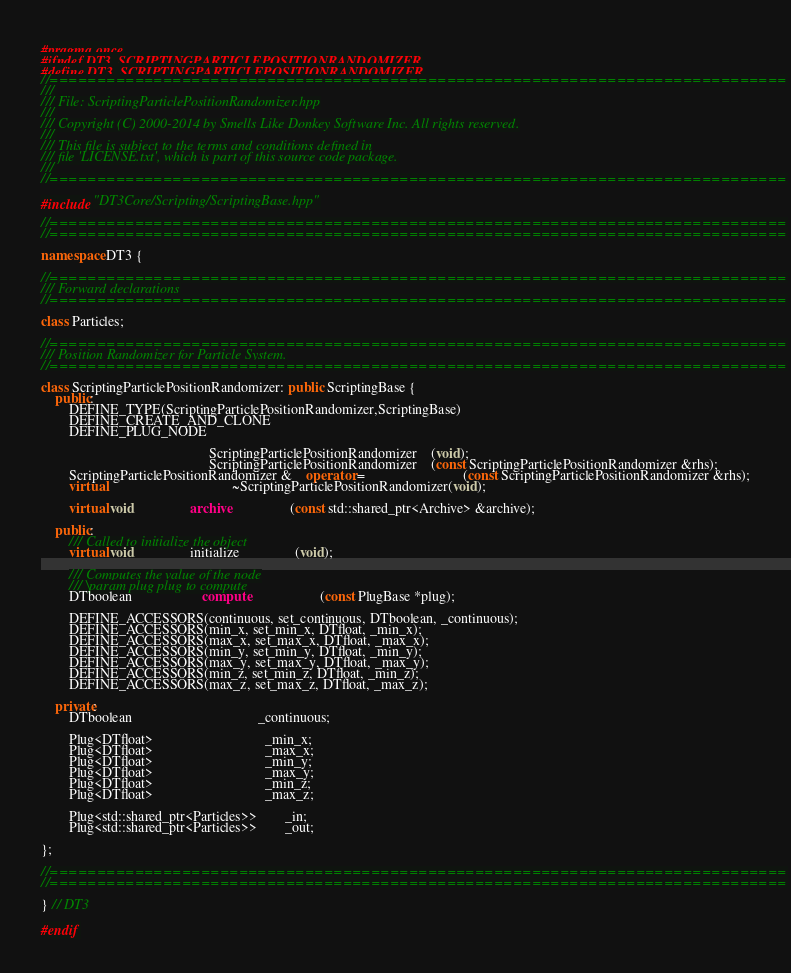<code> <loc_0><loc_0><loc_500><loc_500><_C++_>#pragma once
#ifndef DT3_SCRIPTINGPARTICLEPOSITIONRANDOMIZER
#define DT3_SCRIPTINGPARTICLEPOSITIONRANDOMIZER
//==============================================================================
///
///	File: ScriptingParticlePositionRandomizer.hpp
///
/// Copyright (C) 2000-2014 by Smells Like Donkey Software Inc. All rights reserved.
///
/// This file is subject to the terms and conditions defined in
/// file 'LICENSE.txt', which is part of this source code package.
///
//==============================================================================

#include "DT3Core/Scripting/ScriptingBase.hpp"

//==============================================================================
//==============================================================================

namespace DT3 {

//==============================================================================
/// Forward declarations
//==============================================================================

class Particles;

//==============================================================================
/// Position Randomizer for Particle System.
//==============================================================================

class ScriptingParticlePositionRandomizer: public ScriptingBase {
    public:
        DEFINE_TYPE(ScriptingParticlePositionRandomizer,ScriptingBase)
        DEFINE_CREATE_AND_CLONE
        DEFINE_PLUG_NODE

                                                ScriptingParticlePositionRandomizer	(void);
                                                ScriptingParticlePositionRandomizer	(const ScriptingParticlePositionRandomizer &rhs);
        ScriptingParticlePositionRandomizer &	operator =							(const ScriptingParticlePositionRandomizer &rhs);
        virtual									~ScriptingParticlePositionRandomizer(void);

        virtual void                archive                 (const std::shared_ptr<Archive> &archive);

    public:
        /// Called to initialize the object
        virtual void				initialize				(void);

        /// Computes the value of the node
        /// \param plug plug to compute
        DTboolean					compute					(const PlugBase *plug);

        DEFINE_ACCESSORS(continuous, set_continuous, DTboolean, _continuous);
        DEFINE_ACCESSORS(min_x, set_min_x, DTfloat, _min_x);
        DEFINE_ACCESSORS(max_x, set_max_x, DTfloat, _max_x);
        DEFINE_ACCESSORS(min_y, set_min_y, DTfloat, _min_y);
        DEFINE_ACCESSORS(max_y, set_max_y, DTfloat, _max_y);
        DEFINE_ACCESSORS(min_z, set_min_z, DTfloat, _min_z);
        DEFINE_ACCESSORS(max_z, set_max_z, DTfloat, _max_z);

    private:
        DTboolean									_continuous;

        Plug<DTfloat>								_min_x;
        Plug<DTfloat>								_max_x;
        Plug<DTfloat>								_min_y;
        Plug<DTfloat>								_max_y;
        Plug<DTfloat>								_min_z;
        Plug<DTfloat>								_max_z;

        Plug<std::shared_ptr<Particles>>		_in;
        Plug<std::shared_ptr<Particles>>		_out;

};

//==============================================================================
//==============================================================================

} // DT3

#endif
</code> 